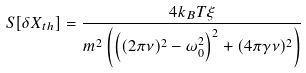Convert formula to latex. <formula><loc_0><loc_0><loc_500><loc_500>S [ \delta X _ { t h } ] = \frac { 4 k _ { B } T \xi } { m ^ { 2 } \left ( \left ( ( 2 \pi \nu ) ^ { 2 } - \omega _ { 0 } ^ { 2 } \right ) ^ { 2 } + ( 4 \pi \gamma \nu ) ^ { 2 } \right ) }</formula> 